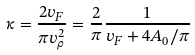Convert formula to latex. <formula><loc_0><loc_0><loc_500><loc_500>\kappa = \frac { 2 v _ { F } } { \pi v _ { \rho } ^ { 2 } } = \frac { 2 } { \pi } \frac { 1 } { v _ { F } + 4 A _ { 0 } / \pi }</formula> 